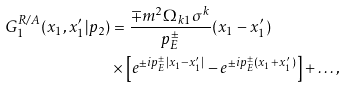Convert formula to latex. <formula><loc_0><loc_0><loc_500><loc_500>G _ { 1 } ^ { R / A } ( x _ { 1 } , x _ { 1 } ^ { \prime } | p _ { 2 } ) & = \frac { \mp m ^ { 2 } \Omega _ { k 1 } \sigma ^ { k } } { p _ { E } ^ { \pm } } ( x _ { 1 } - x _ { 1 } ^ { \prime } ) \\ & \times \left [ e ^ { \pm i p _ { E } ^ { \pm } | x _ { 1 } - x _ { 1 } ^ { \prime } | } - e ^ { \pm i p _ { E } ^ { \pm } ( x _ { 1 } + x _ { 1 } ^ { \prime } ) } \right ] + \dots ,</formula> 